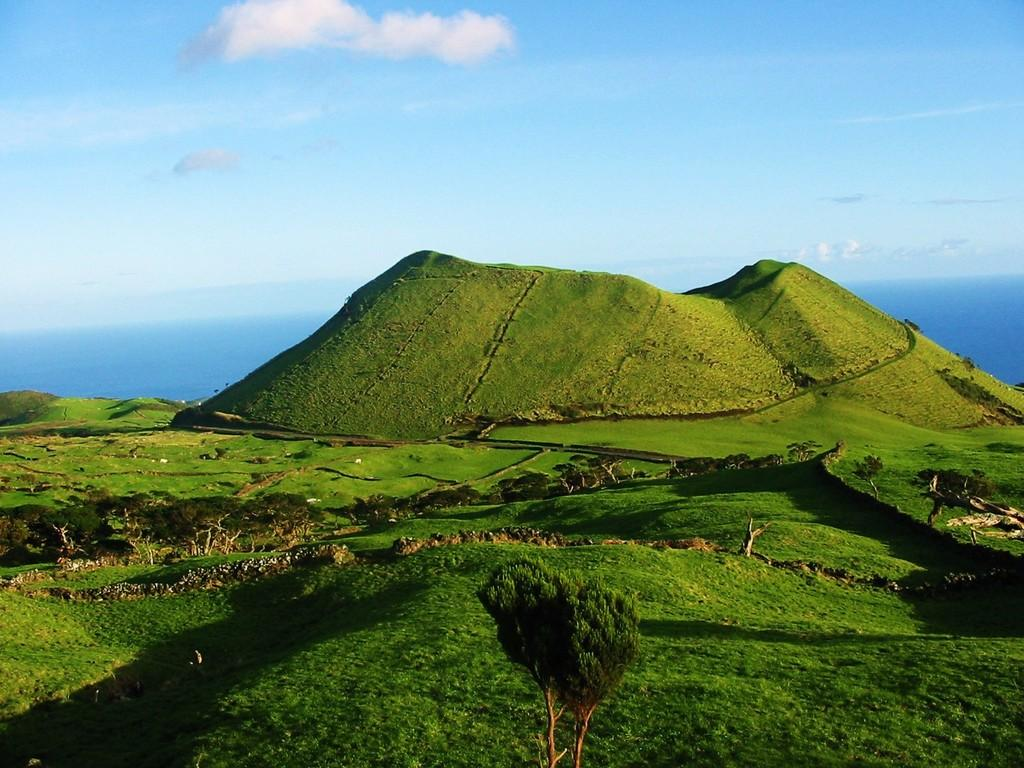What type of vegetation can be seen in the image? There are trees in the image. What else is present on the ground in the image? There is grass and other objects on the ground. What can be seen in the background of the image? The sky and water are visible in the background of the image. What type of book is being read by the fan in the image? There is no book or fan present in the image. 